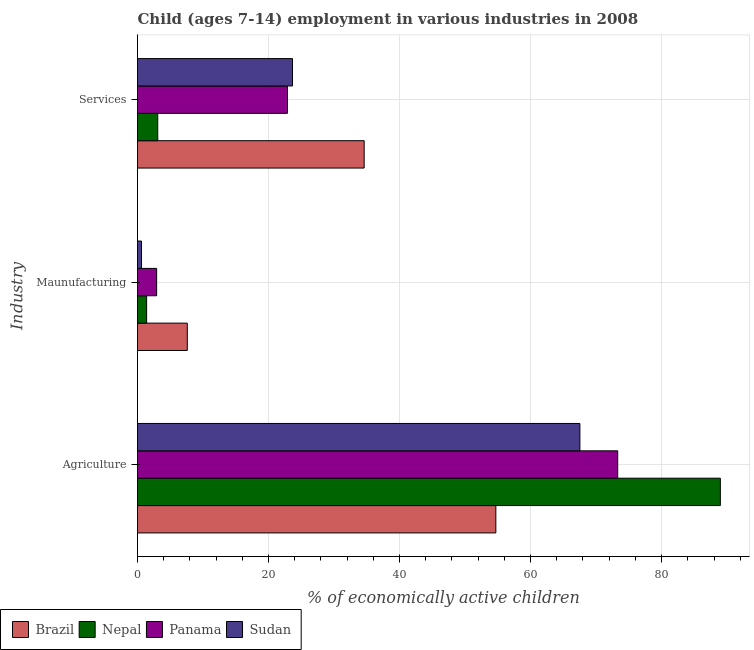Are the number of bars on each tick of the Y-axis equal?
Make the answer very short. Yes. How many bars are there on the 3rd tick from the bottom?
Keep it short and to the point. 4. What is the label of the 2nd group of bars from the top?
Your response must be concise. Maunufacturing. What is the percentage of economically active children in agriculture in Nepal?
Your response must be concise. 88.97. Across all countries, what is the minimum percentage of economically active children in services?
Give a very brief answer. 3.09. In which country was the percentage of economically active children in manufacturing minimum?
Offer a very short reply. Sudan. What is the total percentage of economically active children in services in the graph?
Provide a succinct answer. 84.24. What is the difference between the percentage of economically active children in agriculture in Panama and that in Sudan?
Provide a short and direct response. 5.77. What is the difference between the percentage of economically active children in manufacturing in Nepal and the percentage of economically active children in agriculture in Sudan?
Your answer should be very brief. -66.14. What is the average percentage of economically active children in services per country?
Make the answer very short. 21.06. What is the difference between the percentage of economically active children in manufacturing and percentage of economically active children in agriculture in Brazil?
Offer a terse response. -47.1. In how many countries, is the percentage of economically active children in manufacturing greater than 56 %?
Your answer should be very brief. 0. What is the ratio of the percentage of economically active children in services in Nepal to that in Panama?
Your response must be concise. 0.13. Is the percentage of economically active children in agriculture in Nepal less than that in Brazil?
Keep it short and to the point. No. Is the difference between the percentage of economically active children in services in Nepal and Brazil greater than the difference between the percentage of economically active children in manufacturing in Nepal and Brazil?
Your answer should be very brief. No. What is the difference between the highest and the second highest percentage of economically active children in manufacturing?
Your response must be concise. 4.68. What is the difference between the highest and the lowest percentage of economically active children in agriculture?
Provide a succinct answer. 34.27. Is the sum of the percentage of economically active children in agriculture in Sudan and Brazil greater than the maximum percentage of economically active children in manufacturing across all countries?
Offer a very short reply. Yes. What does the 4th bar from the top in Agriculture represents?
Offer a very short reply. Brazil. What does the 4th bar from the bottom in Maunufacturing represents?
Your response must be concise. Sudan. Is it the case that in every country, the sum of the percentage of economically active children in agriculture and percentage of economically active children in manufacturing is greater than the percentage of economically active children in services?
Your answer should be compact. Yes. How many bars are there?
Offer a terse response. 12. How many countries are there in the graph?
Your response must be concise. 4. What is the difference between two consecutive major ticks on the X-axis?
Offer a very short reply. 20. Does the graph contain any zero values?
Your response must be concise. No. What is the title of the graph?
Give a very brief answer. Child (ages 7-14) employment in various industries in 2008. What is the label or title of the X-axis?
Ensure brevity in your answer.  % of economically active children. What is the label or title of the Y-axis?
Your response must be concise. Industry. What is the % of economically active children of Brazil in Agriculture?
Provide a succinct answer. 54.7. What is the % of economically active children in Nepal in Agriculture?
Offer a very short reply. 88.97. What is the % of economically active children of Panama in Agriculture?
Offer a terse response. 73.3. What is the % of economically active children of Sudan in Agriculture?
Provide a short and direct response. 67.53. What is the % of economically active children in Nepal in Maunufacturing?
Ensure brevity in your answer.  1.39. What is the % of economically active children in Panama in Maunufacturing?
Your answer should be very brief. 2.92. What is the % of economically active children of Sudan in Maunufacturing?
Your answer should be compact. 0.61. What is the % of economically active children of Brazil in Services?
Make the answer very short. 34.6. What is the % of economically active children of Nepal in Services?
Your response must be concise. 3.09. What is the % of economically active children in Panama in Services?
Ensure brevity in your answer.  22.89. What is the % of economically active children of Sudan in Services?
Your answer should be compact. 23.66. Across all Industry, what is the maximum % of economically active children of Brazil?
Your response must be concise. 54.7. Across all Industry, what is the maximum % of economically active children of Nepal?
Provide a succinct answer. 88.97. Across all Industry, what is the maximum % of economically active children of Panama?
Your answer should be very brief. 73.3. Across all Industry, what is the maximum % of economically active children of Sudan?
Provide a short and direct response. 67.53. Across all Industry, what is the minimum % of economically active children of Brazil?
Give a very brief answer. 7.6. Across all Industry, what is the minimum % of economically active children of Nepal?
Provide a succinct answer. 1.39. Across all Industry, what is the minimum % of economically active children in Panama?
Make the answer very short. 2.92. Across all Industry, what is the minimum % of economically active children in Sudan?
Your answer should be compact. 0.61. What is the total % of economically active children in Brazil in the graph?
Provide a succinct answer. 96.9. What is the total % of economically active children of Nepal in the graph?
Offer a very short reply. 93.45. What is the total % of economically active children in Panama in the graph?
Make the answer very short. 99.11. What is the total % of economically active children of Sudan in the graph?
Your answer should be compact. 91.8. What is the difference between the % of economically active children of Brazil in Agriculture and that in Maunufacturing?
Your response must be concise. 47.1. What is the difference between the % of economically active children in Nepal in Agriculture and that in Maunufacturing?
Your response must be concise. 87.58. What is the difference between the % of economically active children in Panama in Agriculture and that in Maunufacturing?
Ensure brevity in your answer.  70.38. What is the difference between the % of economically active children in Sudan in Agriculture and that in Maunufacturing?
Offer a terse response. 66.92. What is the difference between the % of economically active children in Brazil in Agriculture and that in Services?
Provide a succinct answer. 20.1. What is the difference between the % of economically active children in Nepal in Agriculture and that in Services?
Give a very brief answer. 85.88. What is the difference between the % of economically active children of Panama in Agriculture and that in Services?
Your answer should be very brief. 50.41. What is the difference between the % of economically active children in Sudan in Agriculture and that in Services?
Your answer should be compact. 43.87. What is the difference between the % of economically active children in Nepal in Maunufacturing and that in Services?
Provide a short and direct response. -1.7. What is the difference between the % of economically active children in Panama in Maunufacturing and that in Services?
Ensure brevity in your answer.  -19.97. What is the difference between the % of economically active children in Sudan in Maunufacturing and that in Services?
Keep it short and to the point. -23.05. What is the difference between the % of economically active children of Brazil in Agriculture and the % of economically active children of Nepal in Maunufacturing?
Give a very brief answer. 53.31. What is the difference between the % of economically active children in Brazil in Agriculture and the % of economically active children in Panama in Maunufacturing?
Keep it short and to the point. 51.78. What is the difference between the % of economically active children in Brazil in Agriculture and the % of economically active children in Sudan in Maunufacturing?
Offer a terse response. 54.09. What is the difference between the % of economically active children of Nepal in Agriculture and the % of economically active children of Panama in Maunufacturing?
Give a very brief answer. 86.05. What is the difference between the % of economically active children of Nepal in Agriculture and the % of economically active children of Sudan in Maunufacturing?
Ensure brevity in your answer.  88.36. What is the difference between the % of economically active children in Panama in Agriculture and the % of economically active children in Sudan in Maunufacturing?
Your response must be concise. 72.69. What is the difference between the % of economically active children of Brazil in Agriculture and the % of economically active children of Nepal in Services?
Make the answer very short. 51.61. What is the difference between the % of economically active children of Brazil in Agriculture and the % of economically active children of Panama in Services?
Keep it short and to the point. 31.81. What is the difference between the % of economically active children of Brazil in Agriculture and the % of economically active children of Sudan in Services?
Your answer should be compact. 31.04. What is the difference between the % of economically active children in Nepal in Agriculture and the % of economically active children in Panama in Services?
Make the answer very short. 66.08. What is the difference between the % of economically active children of Nepal in Agriculture and the % of economically active children of Sudan in Services?
Make the answer very short. 65.31. What is the difference between the % of economically active children in Panama in Agriculture and the % of economically active children in Sudan in Services?
Your response must be concise. 49.64. What is the difference between the % of economically active children of Brazil in Maunufacturing and the % of economically active children of Nepal in Services?
Provide a succinct answer. 4.51. What is the difference between the % of economically active children in Brazil in Maunufacturing and the % of economically active children in Panama in Services?
Make the answer very short. -15.29. What is the difference between the % of economically active children of Brazil in Maunufacturing and the % of economically active children of Sudan in Services?
Make the answer very short. -16.06. What is the difference between the % of economically active children in Nepal in Maunufacturing and the % of economically active children in Panama in Services?
Offer a terse response. -21.5. What is the difference between the % of economically active children in Nepal in Maunufacturing and the % of economically active children in Sudan in Services?
Your response must be concise. -22.27. What is the difference between the % of economically active children of Panama in Maunufacturing and the % of economically active children of Sudan in Services?
Provide a short and direct response. -20.74. What is the average % of economically active children of Brazil per Industry?
Your answer should be very brief. 32.3. What is the average % of economically active children of Nepal per Industry?
Offer a very short reply. 31.15. What is the average % of economically active children in Panama per Industry?
Provide a short and direct response. 33.04. What is the average % of economically active children of Sudan per Industry?
Provide a succinct answer. 30.6. What is the difference between the % of economically active children in Brazil and % of economically active children in Nepal in Agriculture?
Offer a terse response. -34.27. What is the difference between the % of economically active children of Brazil and % of economically active children of Panama in Agriculture?
Provide a short and direct response. -18.6. What is the difference between the % of economically active children in Brazil and % of economically active children in Sudan in Agriculture?
Ensure brevity in your answer.  -12.83. What is the difference between the % of economically active children in Nepal and % of economically active children in Panama in Agriculture?
Your answer should be compact. 15.67. What is the difference between the % of economically active children of Nepal and % of economically active children of Sudan in Agriculture?
Offer a terse response. 21.44. What is the difference between the % of economically active children in Panama and % of economically active children in Sudan in Agriculture?
Give a very brief answer. 5.77. What is the difference between the % of economically active children of Brazil and % of economically active children of Nepal in Maunufacturing?
Your answer should be very brief. 6.21. What is the difference between the % of economically active children of Brazil and % of economically active children of Panama in Maunufacturing?
Your response must be concise. 4.68. What is the difference between the % of economically active children in Brazil and % of economically active children in Sudan in Maunufacturing?
Offer a very short reply. 6.99. What is the difference between the % of economically active children of Nepal and % of economically active children of Panama in Maunufacturing?
Provide a succinct answer. -1.53. What is the difference between the % of economically active children in Nepal and % of economically active children in Sudan in Maunufacturing?
Keep it short and to the point. 0.78. What is the difference between the % of economically active children of Panama and % of economically active children of Sudan in Maunufacturing?
Offer a very short reply. 2.31. What is the difference between the % of economically active children in Brazil and % of economically active children in Nepal in Services?
Your answer should be compact. 31.51. What is the difference between the % of economically active children of Brazil and % of economically active children of Panama in Services?
Your answer should be very brief. 11.71. What is the difference between the % of economically active children in Brazil and % of economically active children in Sudan in Services?
Ensure brevity in your answer.  10.94. What is the difference between the % of economically active children in Nepal and % of economically active children in Panama in Services?
Offer a very short reply. -19.8. What is the difference between the % of economically active children in Nepal and % of economically active children in Sudan in Services?
Your answer should be very brief. -20.57. What is the difference between the % of economically active children in Panama and % of economically active children in Sudan in Services?
Keep it short and to the point. -0.77. What is the ratio of the % of economically active children of Brazil in Agriculture to that in Maunufacturing?
Provide a short and direct response. 7.2. What is the ratio of the % of economically active children in Nepal in Agriculture to that in Maunufacturing?
Keep it short and to the point. 64.01. What is the ratio of the % of economically active children of Panama in Agriculture to that in Maunufacturing?
Offer a terse response. 25.1. What is the ratio of the % of economically active children in Sudan in Agriculture to that in Maunufacturing?
Your answer should be compact. 110.7. What is the ratio of the % of economically active children in Brazil in Agriculture to that in Services?
Keep it short and to the point. 1.58. What is the ratio of the % of economically active children of Nepal in Agriculture to that in Services?
Provide a succinct answer. 28.79. What is the ratio of the % of economically active children in Panama in Agriculture to that in Services?
Provide a succinct answer. 3.2. What is the ratio of the % of economically active children in Sudan in Agriculture to that in Services?
Give a very brief answer. 2.85. What is the ratio of the % of economically active children of Brazil in Maunufacturing to that in Services?
Offer a very short reply. 0.22. What is the ratio of the % of economically active children in Nepal in Maunufacturing to that in Services?
Your answer should be very brief. 0.45. What is the ratio of the % of economically active children of Panama in Maunufacturing to that in Services?
Provide a short and direct response. 0.13. What is the ratio of the % of economically active children in Sudan in Maunufacturing to that in Services?
Your answer should be compact. 0.03. What is the difference between the highest and the second highest % of economically active children of Brazil?
Offer a very short reply. 20.1. What is the difference between the highest and the second highest % of economically active children in Nepal?
Offer a very short reply. 85.88. What is the difference between the highest and the second highest % of economically active children in Panama?
Your answer should be very brief. 50.41. What is the difference between the highest and the second highest % of economically active children of Sudan?
Keep it short and to the point. 43.87. What is the difference between the highest and the lowest % of economically active children in Brazil?
Your response must be concise. 47.1. What is the difference between the highest and the lowest % of economically active children in Nepal?
Give a very brief answer. 87.58. What is the difference between the highest and the lowest % of economically active children of Panama?
Provide a succinct answer. 70.38. What is the difference between the highest and the lowest % of economically active children of Sudan?
Offer a very short reply. 66.92. 